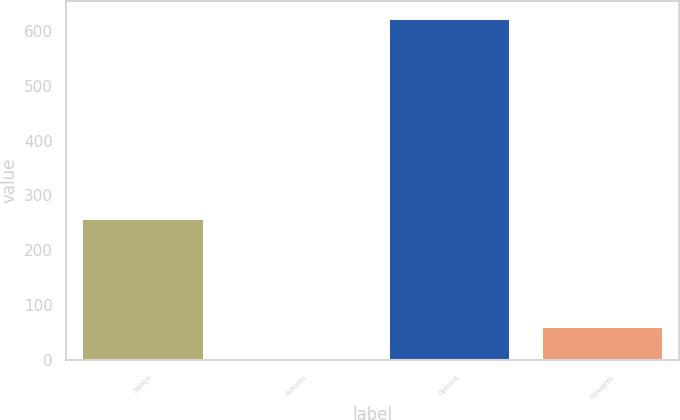<chart> <loc_0><loc_0><loc_500><loc_500><bar_chart><fcel>Swaps<fcel>Futures<fcel>Options<fcel>Forwards<nl><fcel>259<fcel>1<fcel>623<fcel>63.2<nl></chart> 